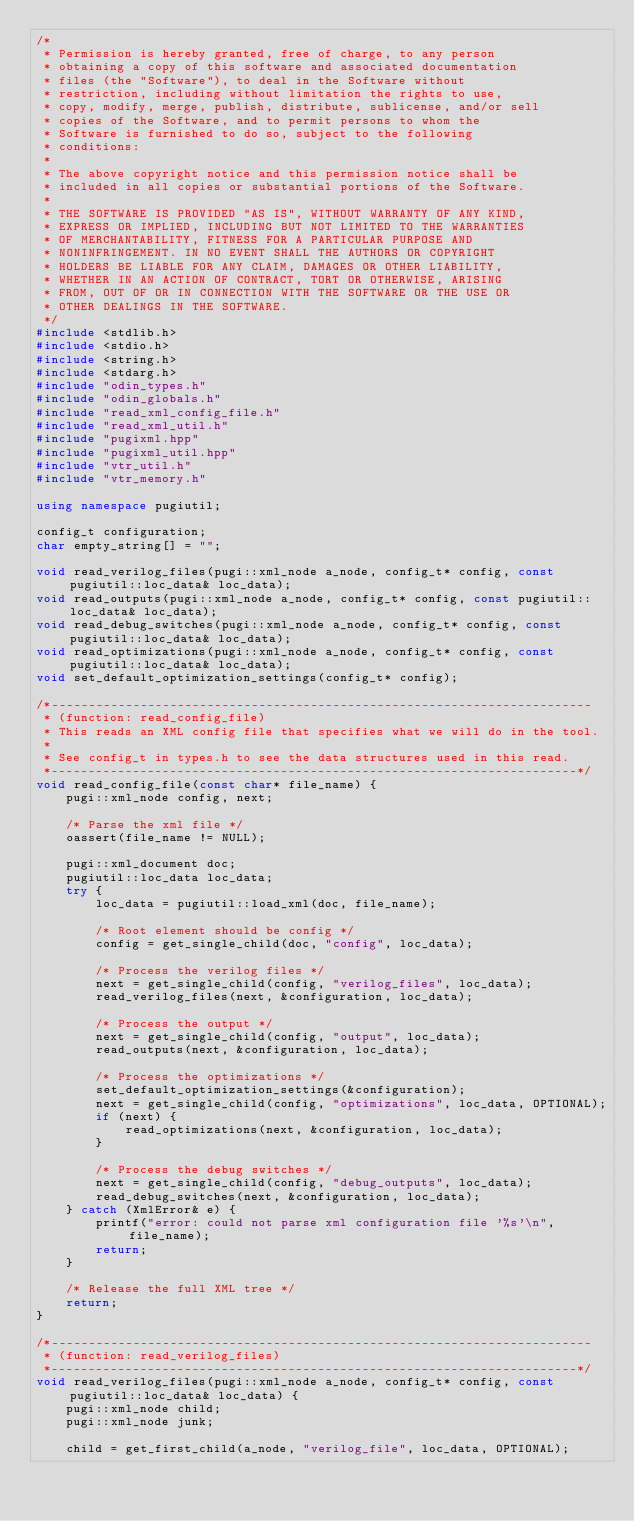<code> <loc_0><loc_0><loc_500><loc_500><_C++_>/*
 * Permission is hereby granted, free of charge, to any person
 * obtaining a copy of this software and associated documentation
 * files (the "Software"), to deal in the Software without
 * restriction, including without limitation the rights to use,
 * copy, modify, merge, publish, distribute, sublicense, and/or sell
 * copies of the Software, and to permit persons to whom the
 * Software is furnished to do so, subject to the following
 * conditions:
 *
 * The above copyright notice and this permission notice shall be
 * included in all copies or substantial portions of the Software.
 *
 * THE SOFTWARE IS PROVIDED "AS IS", WITHOUT WARRANTY OF ANY KIND,
 * EXPRESS OR IMPLIED, INCLUDING BUT NOT LIMITED TO THE WARRANTIES
 * OF MERCHANTABILITY, FITNESS FOR A PARTICULAR PURPOSE AND
 * NONINFRINGEMENT. IN NO EVENT SHALL THE AUTHORS OR COPYRIGHT
 * HOLDERS BE LIABLE FOR ANY CLAIM, DAMAGES OR OTHER LIABILITY,
 * WHETHER IN AN ACTION OF CONTRACT, TORT OR OTHERWISE, ARISING
 * FROM, OUT OF OR IN CONNECTION WITH THE SOFTWARE OR THE USE OR
 * OTHER DEALINGS IN THE SOFTWARE.
 */
#include <stdlib.h>
#include <stdio.h>
#include <string.h>
#include <stdarg.h>
#include "odin_types.h"
#include "odin_globals.h"
#include "read_xml_config_file.h"
#include "read_xml_util.h"
#include "pugixml.hpp"
#include "pugixml_util.hpp"
#include "vtr_util.h"
#include "vtr_memory.h"

using namespace pugiutil;

config_t configuration;
char empty_string[] = "";

void read_verilog_files(pugi::xml_node a_node, config_t* config, const pugiutil::loc_data& loc_data);
void read_outputs(pugi::xml_node a_node, config_t* config, const pugiutil::loc_data& loc_data);
void read_debug_switches(pugi::xml_node a_node, config_t* config, const pugiutil::loc_data& loc_data);
void read_optimizations(pugi::xml_node a_node, config_t* config, const pugiutil::loc_data& loc_data);
void set_default_optimization_settings(config_t* config);

/*-------------------------------------------------------------------------
 * (function: read_config_file)
 * This reads an XML config file that specifies what we will do in the tool.
 *
 * See config_t in types.h to see the data structures used in this read.
 *-----------------------------------------------------------------------*/
void read_config_file(const char* file_name) {
    pugi::xml_node config, next;

    /* Parse the xml file */
    oassert(file_name != NULL);

    pugi::xml_document doc;
    pugiutil::loc_data loc_data;
    try {
        loc_data = pugiutil::load_xml(doc, file_name);

        /* Root element should be config */
        config = get_single_child(doc, "config", loc_data);

        /* Process the verilog files */
        next = get_single_child(config, "verilog_files", loc_data);
        read_verilog_files(next, &configuration, loc_data);

        /* Process the output */
        next = get_single_child(config, "output", loc_data);
        read_outputs(next, &configuration, loc_data);

        /* Process the optimizations */
        set_default_optimization_settings(&configuration);
        next = get_single_child(config, "optimizations", loc_data, OPTIONAL);
        if (next) {
            read_optimizations(next, &configuration, loc_data);
        }

        /* Process the debug switches */
        next = get_single_child(config, "debug_outputs", loc_data);
        read_debug_switches(next, &configuration, loc_data);
    } catch (XmlError& e) {
        printf("error: could not parse xml configuration file '%s'\n", file_name);
        return;
    }

    /* Release the full XML tree */
    return;
}

/*-------------------------------------------------------------------------
 * (function: read_verilog_files)
 *-----------------------------------------------------------------------*/
void read_verilog_files(pugi::xml_node a_node, config_t* config, const pugiutil::loc_data& loc_data) {
    pugi::xml_node child;
    pugi::xml_node junk;

    child = get_first_child(a_node, "verilog_file", loc_data, OPTIONAL);</code> 